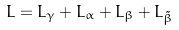<formula> <loc_0><loc_0><loc_500><loc_500>L = L _ { \gamma } + L _ { \alpha } + L _ { \beta } + L _ { \tilde { \beta } }</formula> 